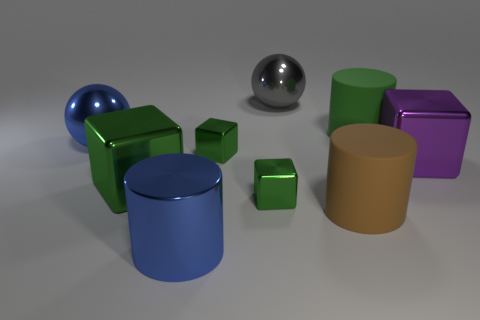Subtract all blue shiny cylinders. How many cylinders are left? 2 Subtract all purple blocks. How many blocks are left? 3 Subtract 1 blocks. How many blocks are left? 3 Subtract all spheres. How many objects are left? 7 Subtract all blue cylinders. Subtract all yellow cubes. How many cylinders are left? 2 Subtract all yellow cylinders. How many green cubes are left? 3 Subtract all tiny brown metallic objects. Subtract all small metallic things. How many objects are left? 7 Add 6 large gray shiny balls. How many large gray shiny balls are left? 7 Add 7 large purple metallic blocks. How many large purple metallic blocks exist? 8 Add 1 blue metallic things. How many objects exist? 10 